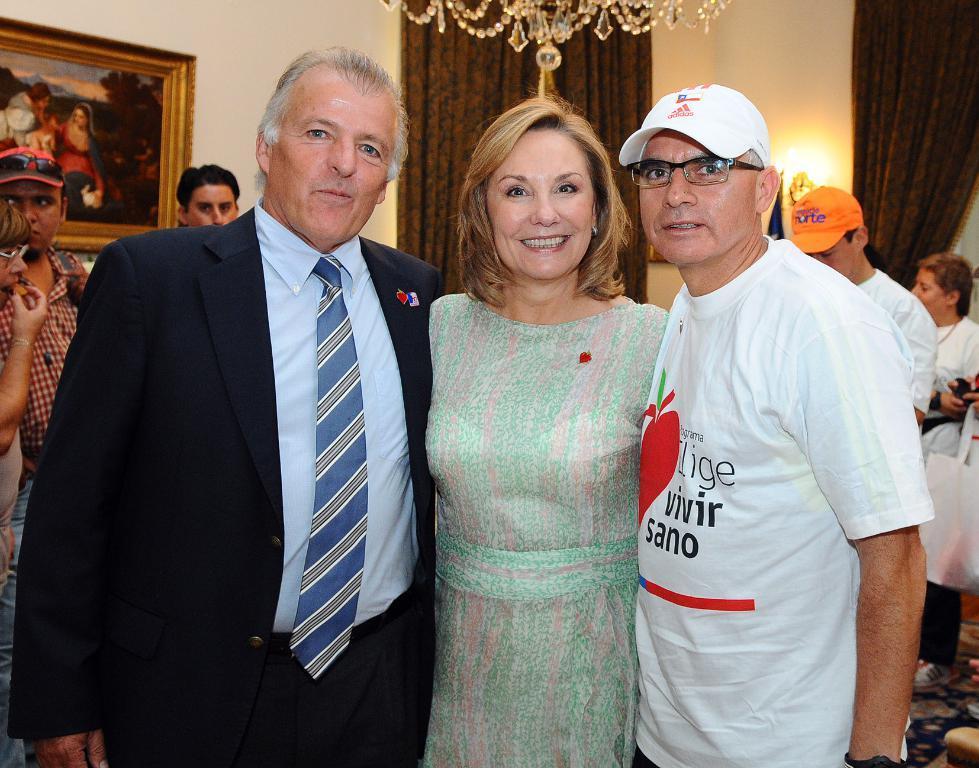Describe this image in one or two sentences. In this picture we can see three persons are standing and smiling in the front, in the background there are some people, we can see a wall, curtains and a light in the background, on the left side there is a photo frame, it looks like a chandelier at the top of the picture. 